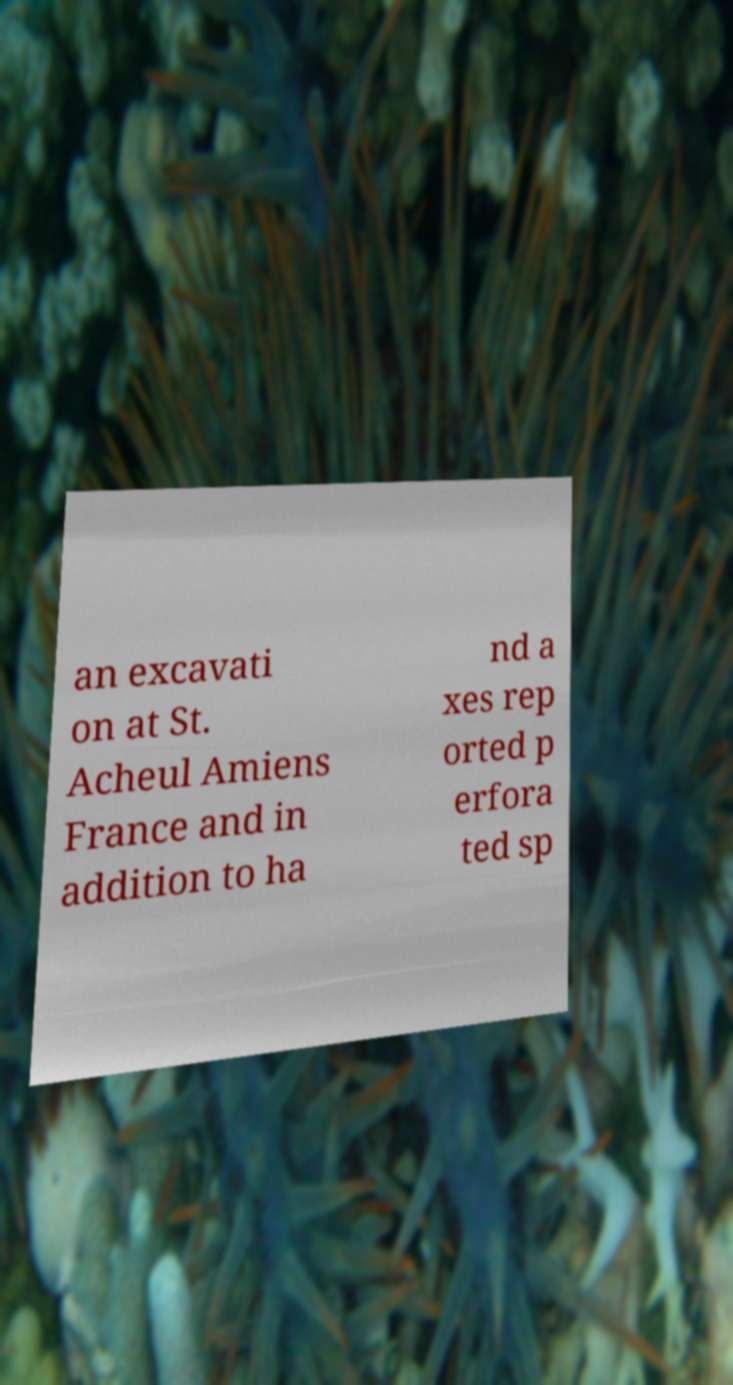I need the written content from this picture converted into text. Can you do that? an excavati on at St. Acheul Amiens France and in addition to ha nd a xes rep orted p erfora ted sp 